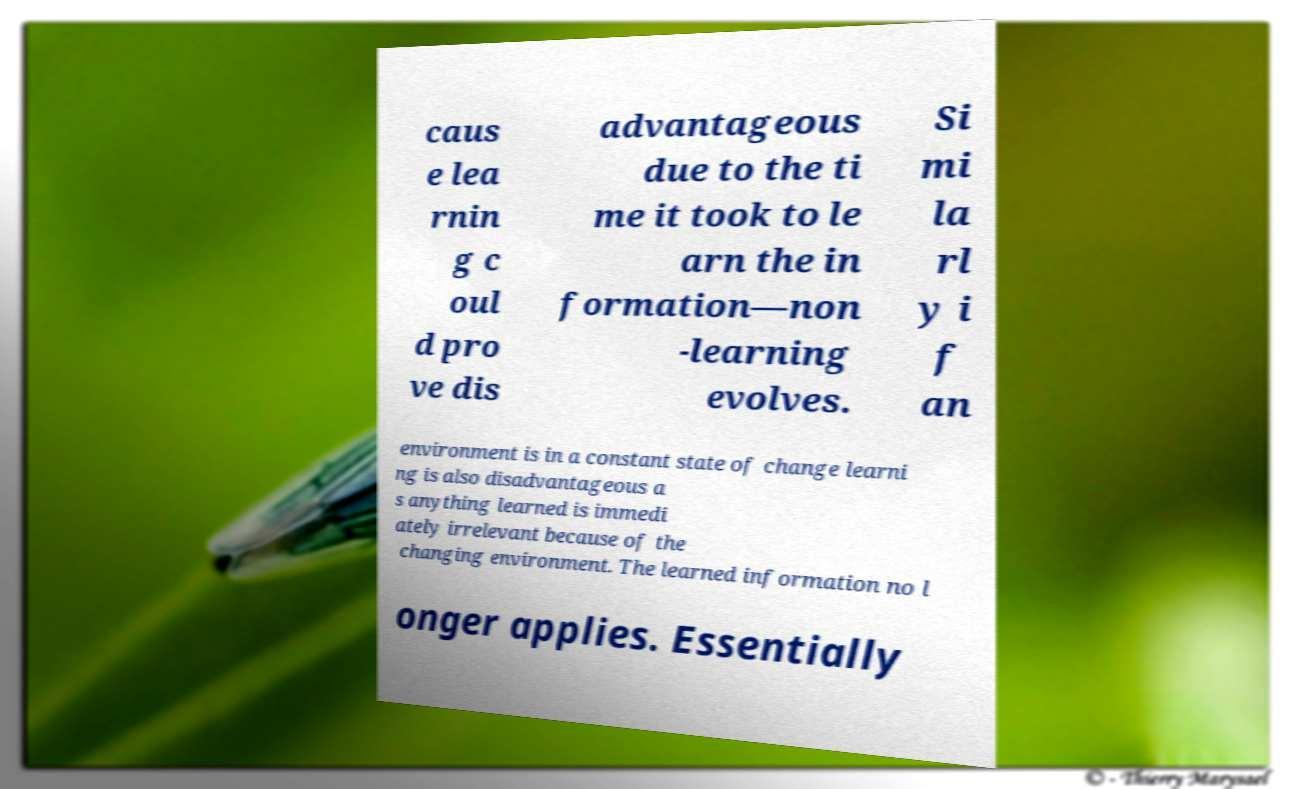What messages or text are displayed in this image? I need them in a readable, typed format. caus e lea rnin g c oul d pro ve dis advantageous due to the ti me it took to le arn the in formation—non -learning evolves. Si mi la rl y i f an environment is in a constant state of change learni ng is also disadvantageous a s anything learned is immedi ately irrelevant because of the changing environment. The learned information no l onger applies. Essentially 